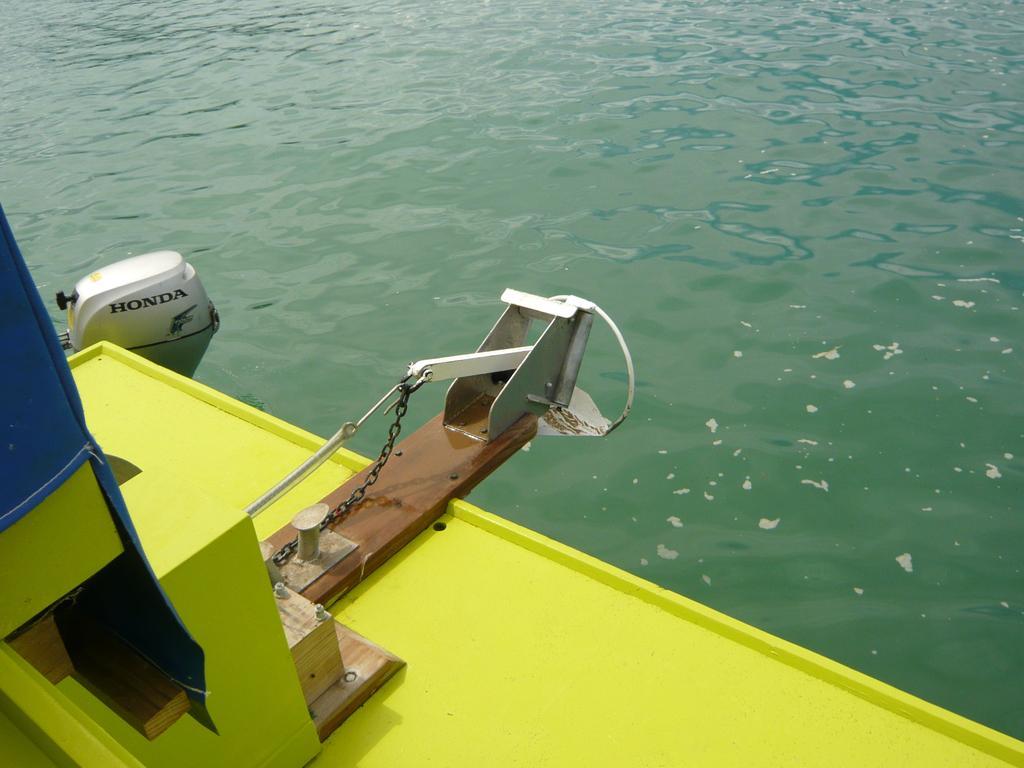Please provide a concise description of this image. On the left side of the image we can see there is a boat, beside boat there are water. 